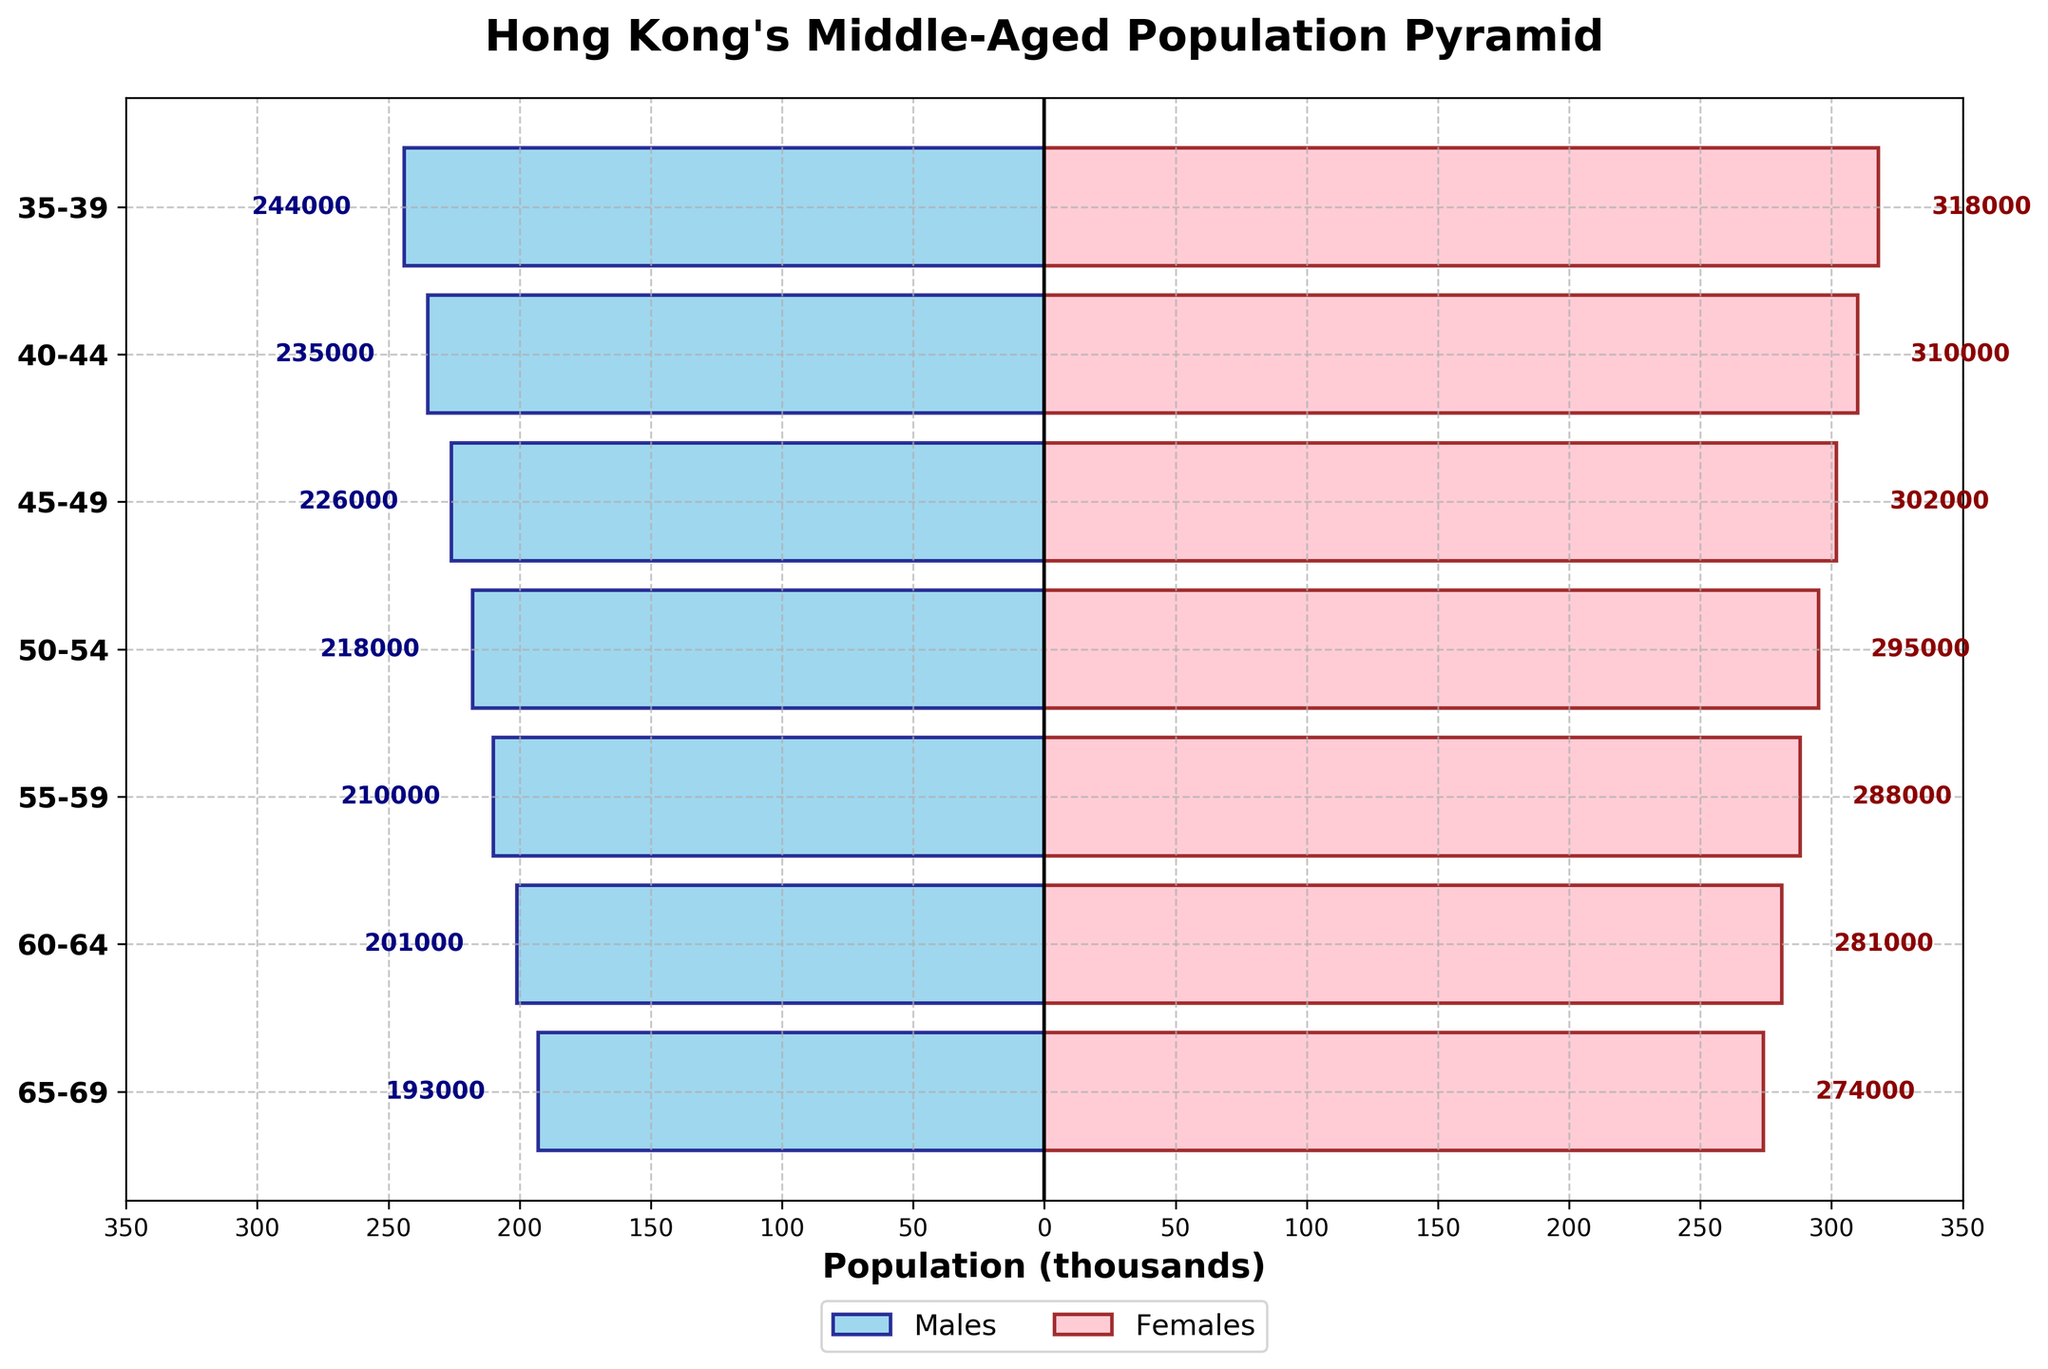What is the age group with the largest population of males? To find the age group with the largest population of males, look at the left side of the population pyramid and identify the bar with the largest magnitude. The range is from 35 to 39 with 244,000.
Answer: 35-39 What is the age group with the smallest population of females? To find the age group with the smallest population of females, look at the right side of the population pyramid and identify the bar with the smallest magnitude. The range is from 65 to 69 with 274,000.
Answer: 65-69 Which gender has more people in the 45-49 age group? To determine which gender has more people in the 45-49 age group, compare the lengths of the bars on both sides corresponding to that age group. The length on the left (males) is 226,000, and the length on the right (females) is 302,000. Since 302,000 is greater, females have more people.
Answer: Females What is the total population of both males and females in the 50-54 age group? To find the total population in the 50-54 age group, add the male and female populations together: 218,000 (males) + 295,000 (females) = 513,000.
Answer: 513,000 How does the population trend change as people move from the 35-39 age group to the 65-69 age group? Examine the heights of the bars from the 35-39 age group to the 65-69 age group for both males and females. Notice that the populations gradually decrease as the age groups increase. For males, it decreases from 244,000 to 193,000, and for females, from 318,000 to 274,000.
Answer: Decreases What is the average population of males across all age groups? Calculate the average population of males by summing the male populations for all age groups and then dividing by the number of age groups. Sum = 244,000 + 235,000 + 226,000 + 218,000 + 210,000 + 201,000 + 193,000 = 1,527,000. Number of age groups = 7. Average = 1,527,000 / 7 ≈ 218,143.
Answer: 218,143 How does the population imbalance between males and females evolve from age group 35-39 to 65-69? Compare the population difference between males and females for each age group and observe any trends. Initially, in the 35-39 age group, the difference is 74,000 more females than males. As age increases, the difference decreases slightly, eventually reaching a population difference of 81,000 in the 65-69 age group.
Answer: Decreases slightly, then stabilizes 